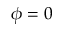<formula> <loc_0><loc_0><loc_500><loc_500>\phi = 0</formula> 